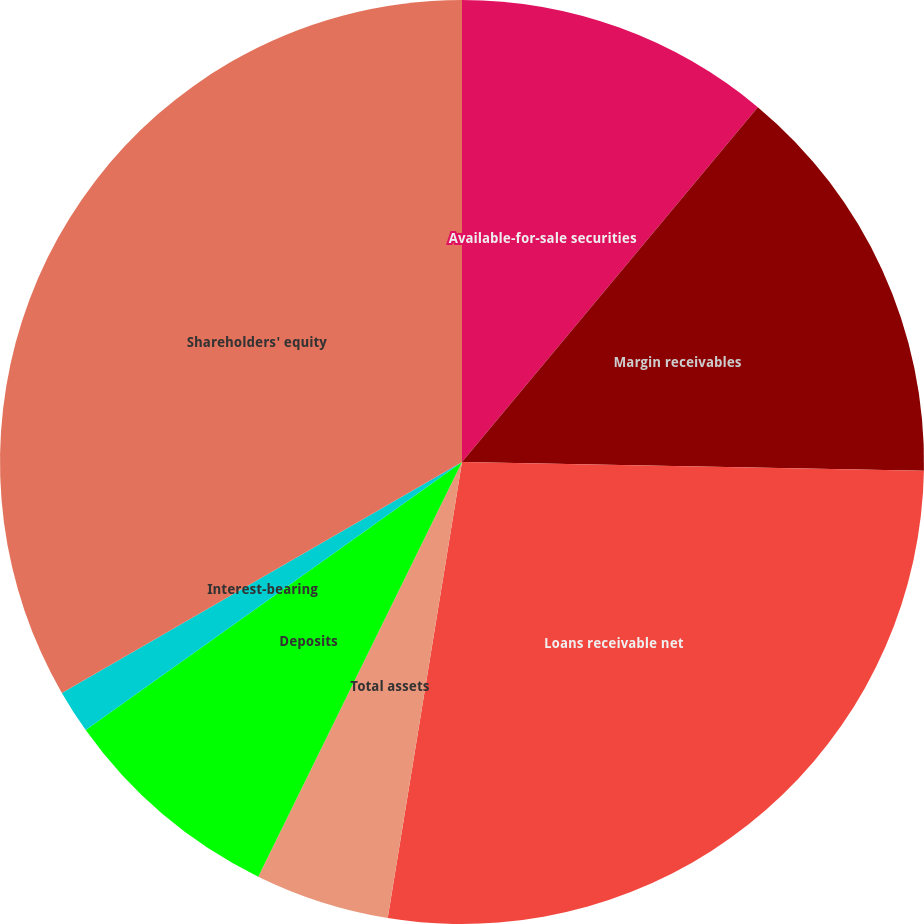Convert chart. <chart><loc_0><loc_0><loc_500><loc_500><pie_chart><fcel>Available-for-sale securities<fcel>Margin receivables<fcel>Loans receivable net<fcel>Total assets<fcel>Deposits<fcel>Interest-bearing<fcel>Shareholders' equity<nl><fcel>11.06%<fcel>14.24%<fcel>27.27%<fcel>4.7%<fcel>7.88%<fcel>1.52%<fcel>33.33%<nl></chart> 